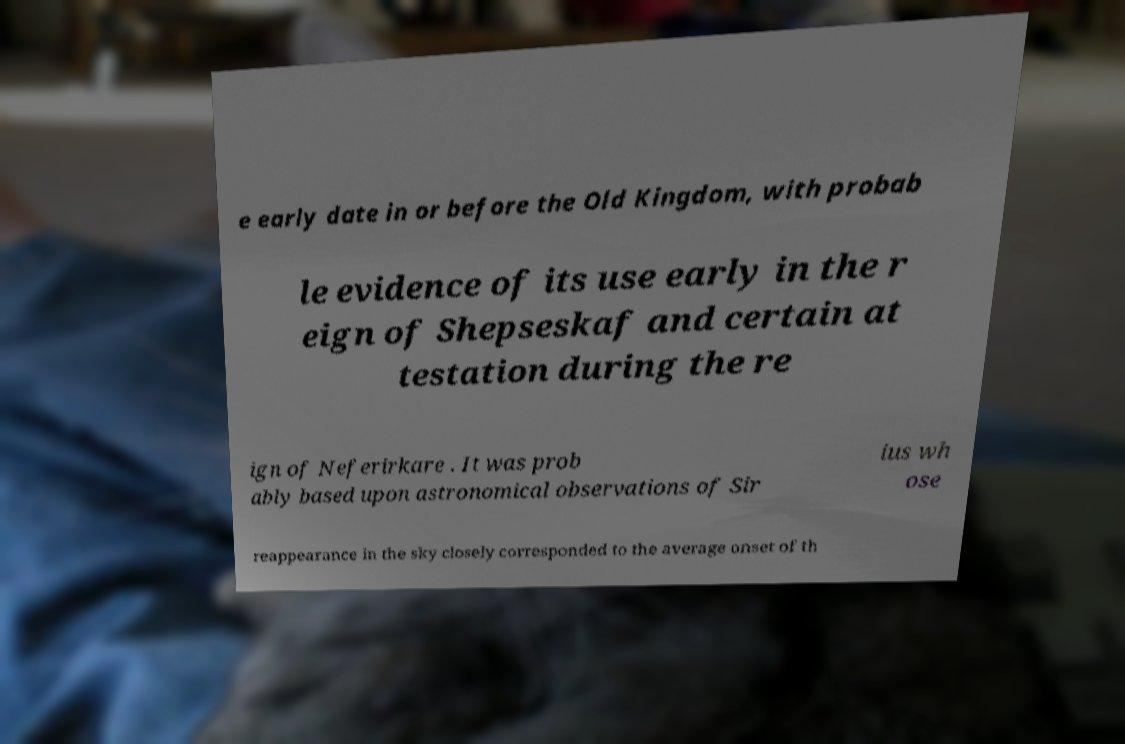Can you accurately transcribe the text from the provided image for me? e early date in or before the Old Kingdom, with probab le evidence of its use early in the r eign of Shepseskaf and certain at testation during the re ign of Neferirkare . It was prob ably based upon astronomical observations of Sir ius wh ose reappearance in the sky closely corresponded to the average onset of th 